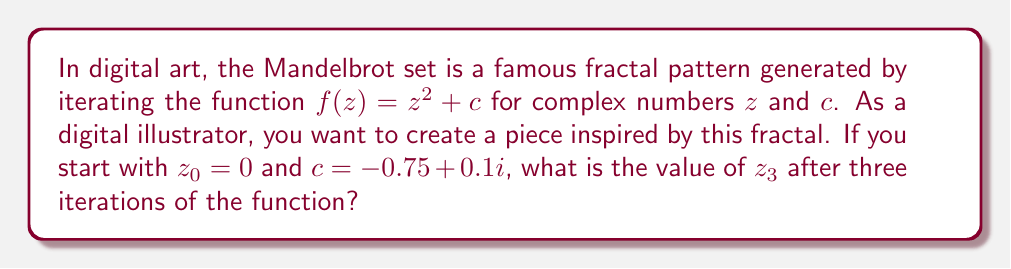Provide a solution to this math problem. Let's iterate the function $f(z) = z^2 + c$ three times, starting with $z_0 = 0$ and $c = -0.75 + 0.1i$:

1. First iteration:
   $z_1 = f(z_0) = z_0^2 + c = 0^2 + (-0.75 + 0.1i) = -0.75 + 0.1i$

2. Second iteration:
   $z_2 = f(z_1) = z_1^2 + c$
   $= (-0.75 + 0.1i)^2 + (-0.75 + 0.1i)$
   $= (0.5625 - 0.15i + 0.01i^2) + (-0.75 + 0.1i)$
   $= (0.5625 - 0.15i - 0.01) + (-0.75 + 0.1i)$
   $= -0.1975 - 0.05i$

3. Third iteration:
   $z_3 = f(z_2) = z_2^2 + c$
   $= (-0.1975 - 0.05i)^2 + (-0.75 + 0.1i)$
   $= (0.039006 + 0.01975i + 0.0025i^2) + (-0.75 + 0.1i)$
   $= (0.039006 + 0.01975i - 0.0025) + (-0.75 + 0.1i)$
   $= -0.713494 + 0.11975i$

Therefore, after three iterations, $z_3 = -0.713494 + 0.11975i$.
Answer: $-0.713494 + 0.11975i$ 